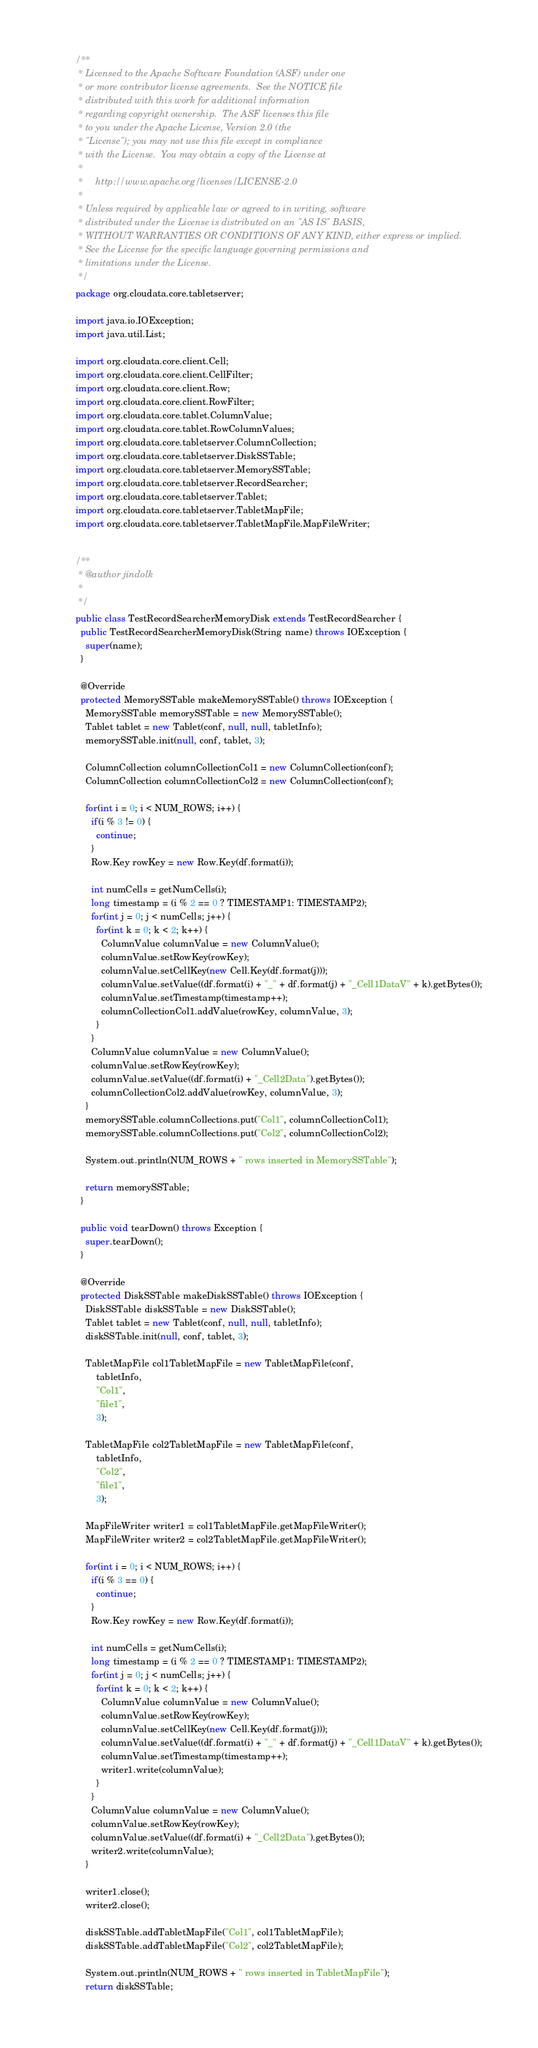Convert code to text. <code><loc_0><loc_0><loc_500><loc_500><_Java_>/**
 * Licensed to the Apache Software Foundation (ASF) under one
 * or more contributor license agreements.  See the NOTICE file
 * distributed with this work for additional information
 * regarding copyright ownership.  The ASF licenses this file
 * to you under the Apache License, Version 2.0 (the
 * "License"); you may not use this file except in compliance
 * with the License.  You may obtain a copy of the License at
 *
 *     http://www.apache.org/licenses/LICENSE-2.0
 *
 * Unless required by applicable law or agreed to in writing, software
 * distributed under the License is distributed on an "AS IS" BASIS,
 * WITHOUT WARRANTIES OR CONDITIONS OF ANY KIND, either express or implied.
 * See the License for the specific language governing permissions and
 * limitations under the License.
 */
package org.cloudata.core.tabletserver;

import java.io.IOException;
import java.util.List;

import org.cloudata.core.client.Cell;
import org.cloudata.core.client.CellFilter;
import org.cloudata.core.client.Row;
import org.cloudata.core.client.RowFilter;
import org.cloudata.core.tablet.ColumnValue;
import org.cloudata.core.tablet.RowColumnValues;
import org.cloudata.core.tabletserver.ColumnCollection;
import org.cloudata.core.tabletserver.DiskSSTable;
import org.cloudata.core.tabletserver.MemorySSTable;
import org.cloudata.core.tabletserver.RecordSearcher;
import org.cloudata.core.tabletserver.Tablet;
import org.cloudata.core.tabletserver.TabletMapFile;
import org.cloudata.core.tabletserver.TabletMapFile.MapFileWriter;


/**
 * @author jindolk
 *
 */
public class TestRecordSearcherMemoryDisk extends TestRecordSearcher {
  public TestRecordSearcherMemoryDisk(String name) throws IOException {
    super(name);
  }

  @Override
  protected MemorySSTable makeMemorySSTable() throws IOException {
    MemorySSTable memorySSTable = new MemorySSTable();
    Tablet tablet = new Tablet(conf, null, null, tabletInfo);
    memorySSTable.init(null, conf, tablet, 3);
    
    ColumnCollection columnCollectionCol1 = new ColumnCollection(conf);
    ColumnCollection columnCollectionCol2 = new ColumnCollection(conf);
    
    for(int i = 0; i < NUM_ROWS; i++) {
      if(i % 3 != 0) {
        continue;
      }
      Row.Key rowKey = new Row.Key(df.format(i));
      
      int numCells = getNumCells(i);
      long timestamp = (i % 2 == 0 ? TIMESTAMP1: TIMESTAMP2);
      for(int j = 0; j < numCells; j++) {
        for(int k = 0; k < 2; k++) {
          ColumnValue columnValue = new ColumnValue();
          columnValue.setRowKey(rowKey);
          columnValue.setCellKey(new Cell.Key(df.format(j)));
          columnValue.setValue((df.format(i) + "_" + df.format(j) + "_Cell1DataV" + k).getBytes());
          columnValue.setTimestamp(timestamp++);
          columnCollectionCol1.addValue(rowKey, columnValue, 3);
        }
      }
      ColumnValue columnValue = new ColumnValue();
      columnValue.setRowKey(rowKey);
      columnValue.setValue((df.format(i) + "_Cell2Data").getBytes());
      columnCollectionCol2.addValue(rowKey, columnValue, 3);
    }
    memorySSTable.columnCollections.put("Col1", columnCollectionCol1);
    memorySSTable.columnCollections.put("Col2", columnCollectionCol2);

    System.out.println(NUM_ROWS + " rows inserted in MemorySSTable");
    
    return memorySSTable;
  }

  public void tearDown() throws Exception {
    super.tearDown();
  }
  
  @Override
  protected DiskSSTable makeDiskSSTable() throws IOException {
    DiskSSTable diskSSTable = new DiskSSTable();
    Tablet tablet = new Tablet(conf, null, null, tabletInfo);
    diskSSTable.init(null, conf, tablet, 3);
    
    TabletMapFile col1TabletMapFile = new TabletMapFile(conf,
        tabletInfo, 
        "Col1",
        "file1", 
        3);

    TabletMapFile col2TabletMapFile = new TabletMapFile(conf,
        tabletInfo, 
        "Col2",
        "file1", 
        3);
    
    MapFileWriter writer1 = col1TabletMapFile.getMapFileWriter();
    MapFileWriter writer2 = col2TabletMapFile.getMapFileWriter();
    
    for(int i = 0; i < NUM_ROWS; i++) {
      if(i % 3 == 0) {
        continue;
      }
      Row.Key rowKey = new Row.Key(df.format(i));

      int numCells = getNumCells(i);
      long timestamp = (i % 2 == 0 ? TIMESTAMP1: TIMESTAMP2);
      for(int j = 0; j < numCells; j++) {
        for(int k = 0; k < 2; k++) {
          ColumnValue columnValue = new ColumnValue();
          columnValue.setRowKey(rowKey);
          columnValue.setCellKey(new Cell.Key(df.format(j)));
          columnValue.setValue((df.format(i) + "_" + df.format(j) + "_Cell1DataV" + k).getBytes());
          columnValue.setTimestamp(timestamp++);
          writer1.write(columnValue);
        }
      }
      ColumnValue columnValue = new ColumnValue();
      columnValue.setRowKey(rowKey);
      columnValue.setValue((df.format(i) + "_Cell2Data").getBytes());
      writer2.write(columnValue);
    }
    
    writer1.close();
    writer2.close();
    
    diskSSTable.addTabletMapFile("Col1", col1TabletMapFile);
    diskSSTable.addTabletMapFile("Col2", col2TabletMapFile);
    
    System.out.println(NUM_ROWS + " rows inserted in TabletMapFile");
    return diskSSTable;</code> 